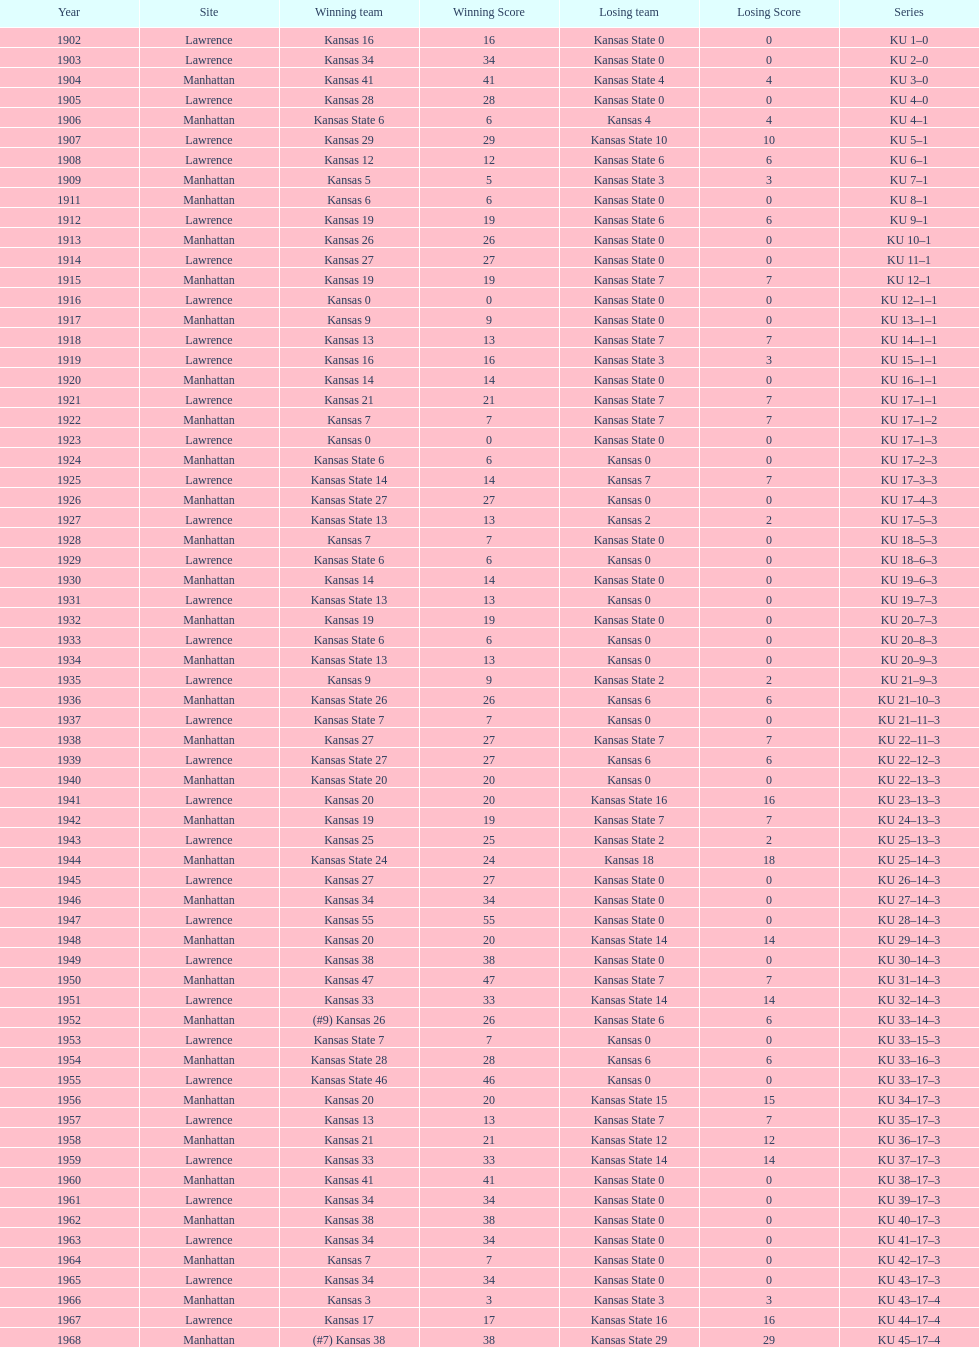What was the number of wins kansas state had in manhattan? 8. 